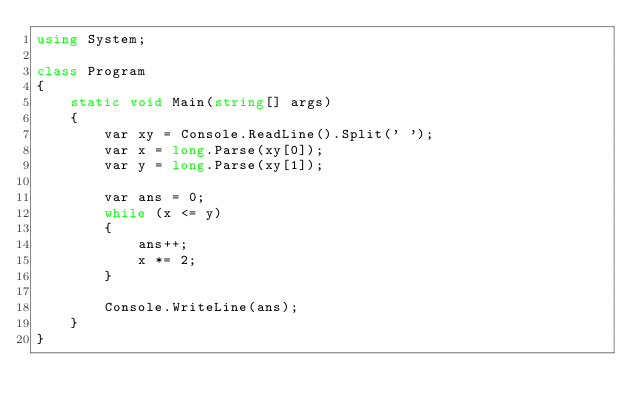Convert code to text. <code><loc_0><loc_0><loc_500><loc_500><_C#_>using System;

class Program
{
    static void Main(string[] args)
    {
        var xy = Console.ReadLine().Split(' ');
        var x = long.Parse(xy[0]);
        var y = long.Parse(xy[1]);

        var ans = 0;
        while (x <= y)
        {
            ans++;
            x *= 2;
        }

        Console.WriteLine(ans);
    }
}</code> 